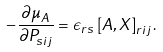<formula> <loc_0><loc_0><loc_500><loc_500>- \frac { \partial \mu _ { A } } { \partial P _ { s i j } } = \epsilon _ { r s } \left [ A , X \right ] _ { r i j } .</formula> 